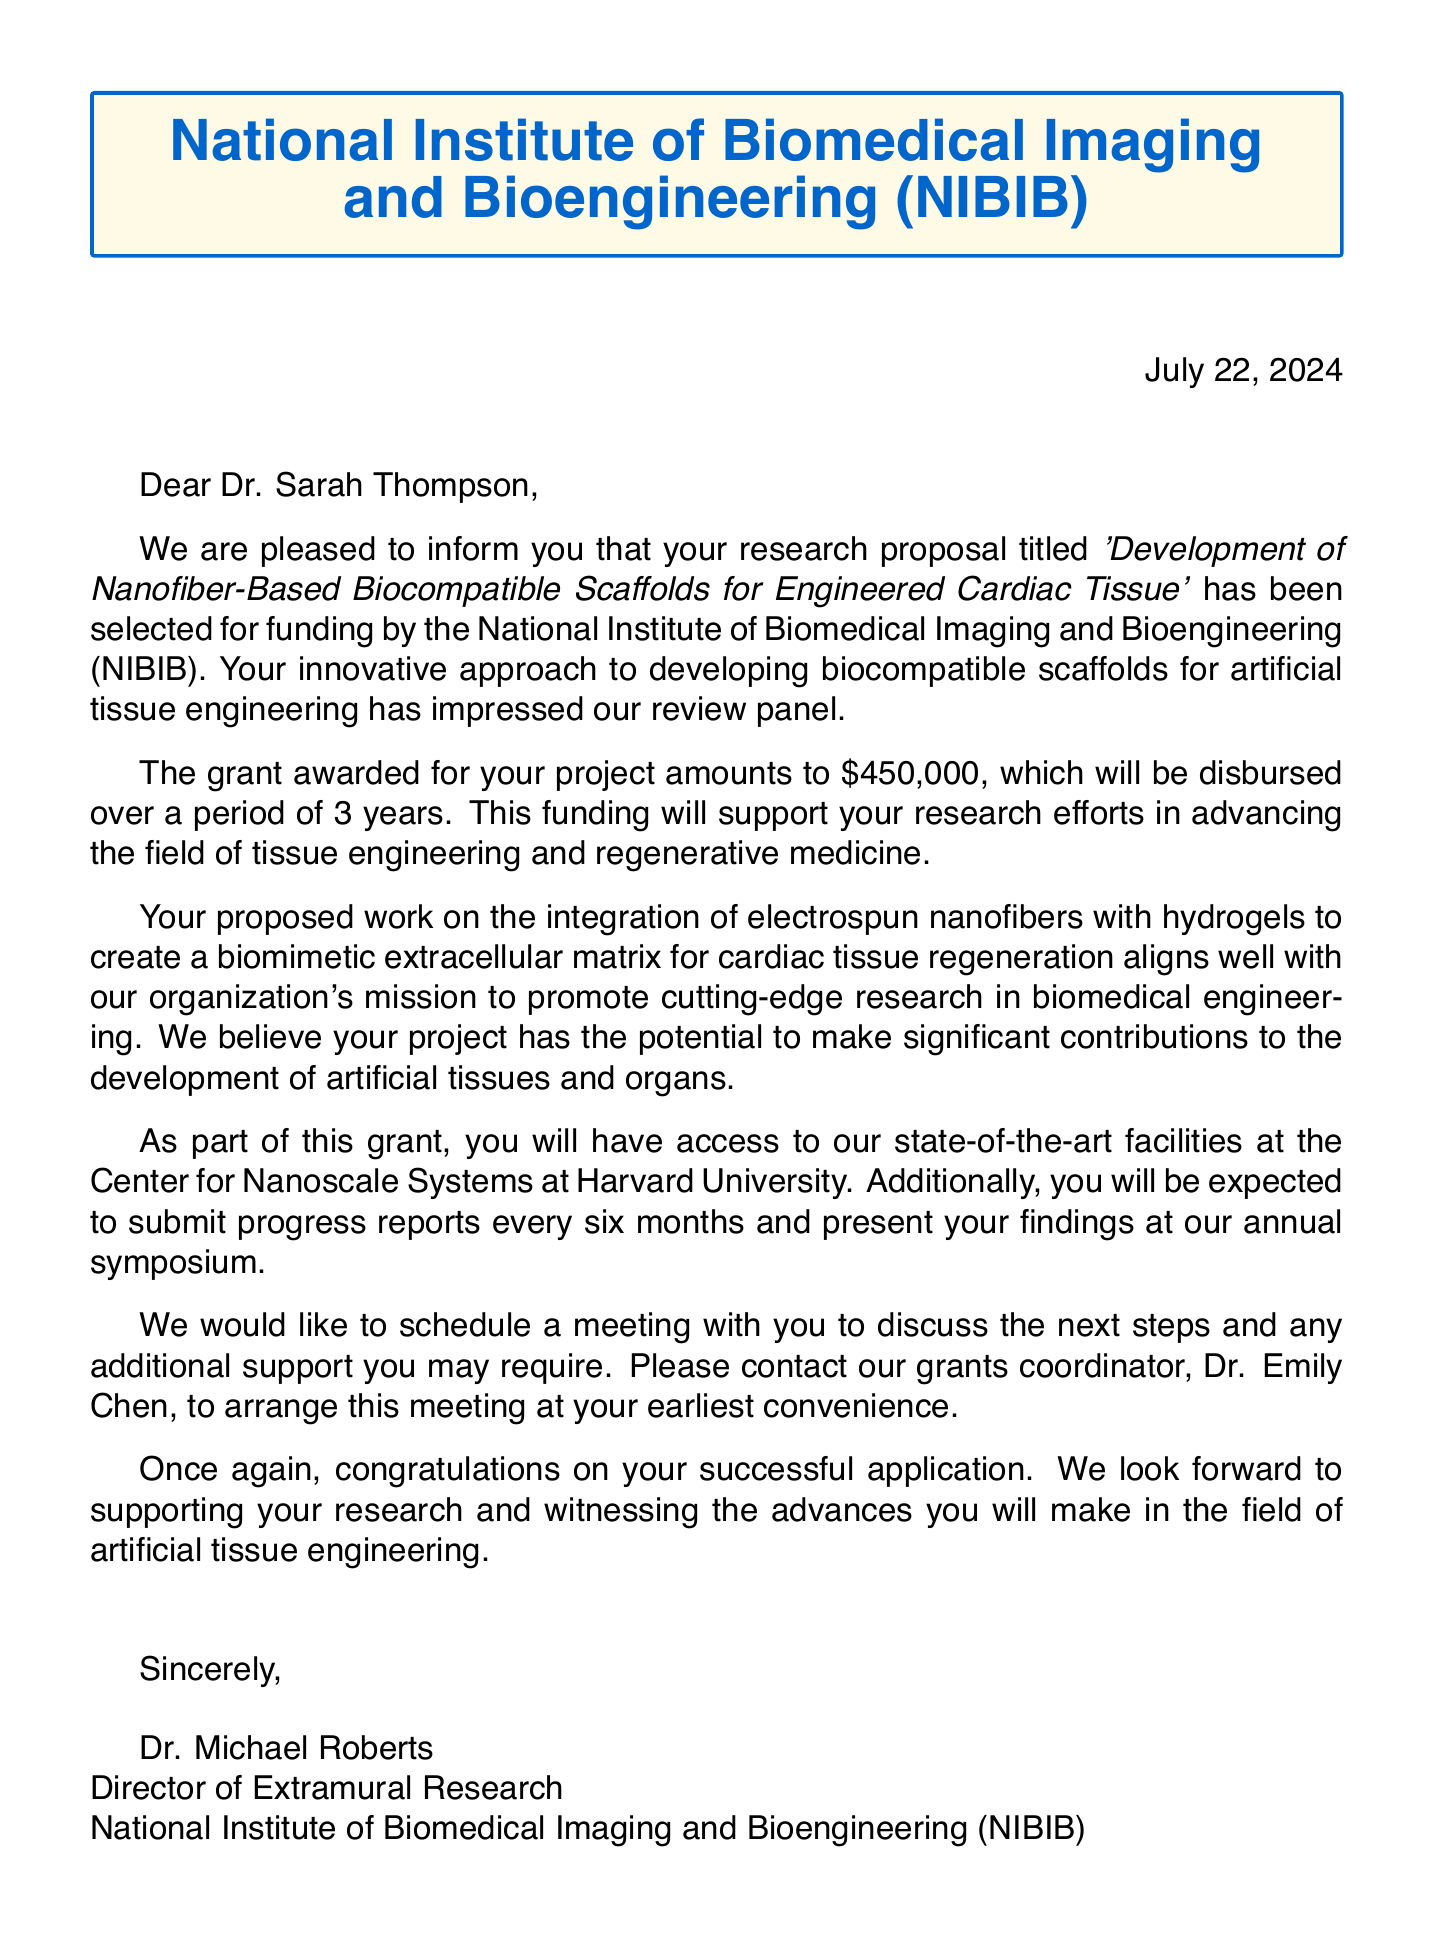What is the title of the research proposal? The title can be found in the opening paragraph of the letter, specifically mentioning the proposed project.
Answer: Development of Nanofiber-Based Biocompatible Scaffolds for Engineered Cardiac Tissue Who is the recipient of the letter? The recipient's name is mentioned in the salutation of the letter.
Answer: Dr. Sarah Thompson What is the amount of grant awarded? The grant amount is clearly stated in the body paragraphs of the letter.
Answer: $450,000 How long is the grant duration? The duration of the grant can be found in the section discussing the financial support provided for the project.
Answer: 3 years What specific aspect of research is highlighted in the letter? The specific aspect is detailed in one of the body paragraphs discussing the research alignment.
Answer: the integration of electrospun nanofibers with hydrogels to create a biomimetic extracellular matrix for cardiac tissue regeneration What is expected from the recipient in terms of reporting? This information is outlined in the paragraph regarding progress expectations associated with the grant.
Answer: every six months Who coordinates the grants? The coordinator's name is provided in the section regarding meeting arrangements for further discussion.
Answer: Dr. Emily Chen What is one of the collaboration opportunities mentioned? Collaboration opportunities are listed in the additional information box toward the end of the document.
Answer: Massachusetts General Hospital's Cardiovascular Research Center What is the sender's title? The sender’s title is mentioned in the signature section of the letter.
Answer: Director of Extramural Research 